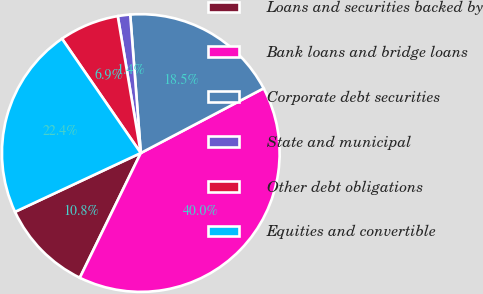<chart> <loc_0><loc_0><loc_500><loc_500><pie_chart><fcel>Loans and securities backed by<fcel>Bank loans and bridge loans<fcel>Corporate debt securities<fcel>State and municipal<fcel>Other debt obligations<fcel>Equities and convertible<nl><fcel>10.8%<fcel>39.95%<fcel>18.5%<fcel>1.44%<fcel>6.95%<fcel>22.36%<nl></chart> 